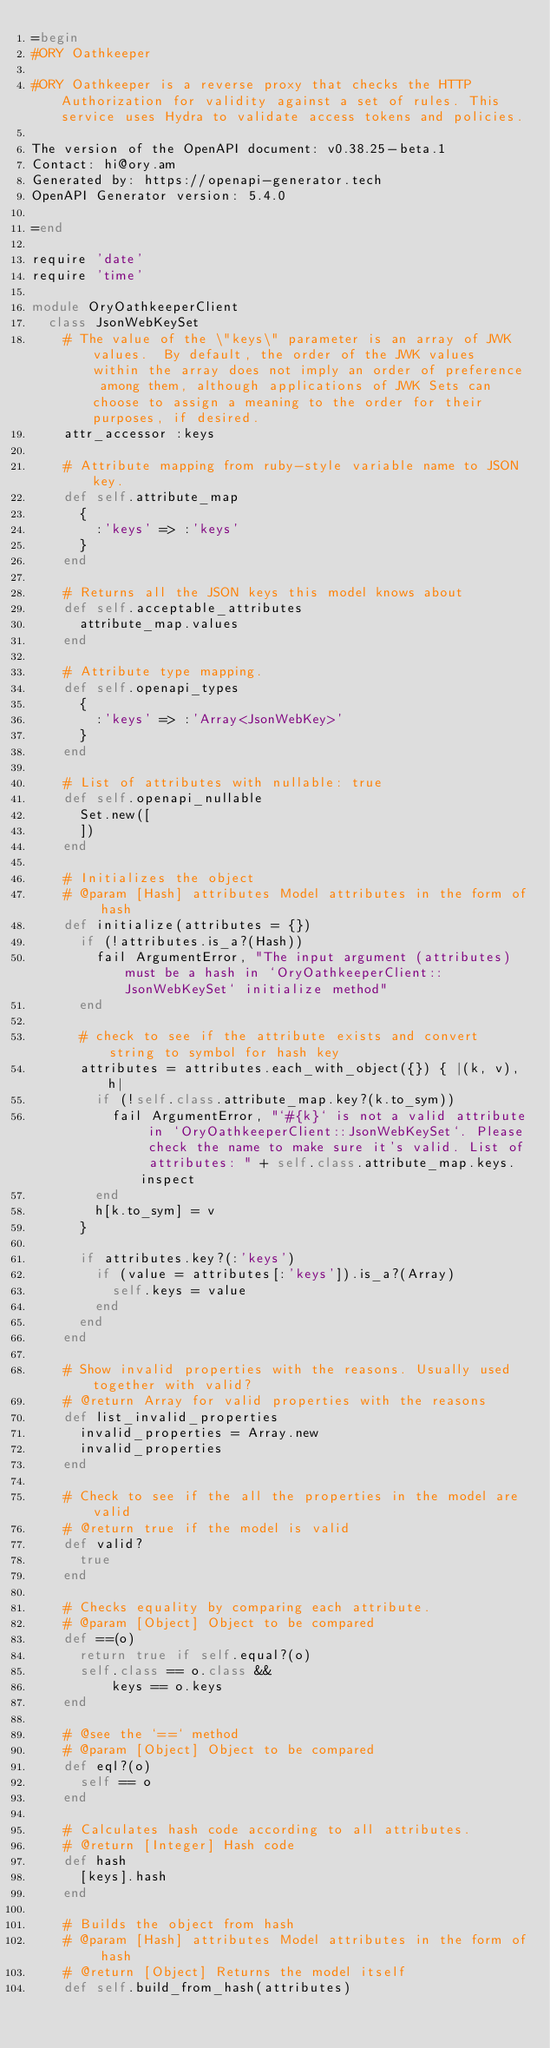<code> <loc_0><loc_0><loc_500><loc_500><_Ruby_>=begin
#ORY Oathkeeper

#ORY Oathkeeper is a reverse proxy that checks the HTTP Authorization for validity against a set of rules. This service uses Hydra to validate access tokens and policies.

The version of the OpenAPI document: v0.38.25-beta.1
Contact: hi@ory.am
Generated by: https://openapi-generator.tech
OpenAPI Generator version: 5.4.0

=end

require 'date'
require 'time'

module OryOathkeeperClient
  class JsonWebKeySet
    # The value of the \"keys\" parameter is an array of JWK values.  By default, the order of the JWK values within the array does not imply an order of preference among them, although applications of JWK Sets can choose to assign a meaning to the order for their purposes, if desired.
    attr_accessor :keys

    # Attribute mapping from ruby-style variable name to JSON key.
    def self.attribute_map
      {
        :'keys' => :'keys'
      }
    end

    # Returns all the JSON keys this model knows about
    def self.acceptable_attributes
      attribute_map.values
    end

    # Attribute type mapping.
    def self.openapi_types
      {
        :'keys' => :'Array<JsonWebKey>'
      }
    end

    # List of attributes with nullable: true
    def self.openapi_nullable
      Set.new([
      ])
    end

    # Initializes the object
    # @param [Hash] attributes Model attributes in the form of hash
    def initialize(attributes = {})
      if (!attributes.is_a?(Hash))
        fail ArgumentError, "The input argument (attributes) must be a hash in `OryOathkeeperClient::JsonWebKeySet` initialize method"
      end

      # check to see if the attribute exists and convert string to symbol for hash key
      attributes = attributes.each_with_object({}) { |(k, v), h|
        if (!self.class.attribute_map.key?(k.to_sym))
          fail ArgumentError, "`#{k}` is not a valid attribute in `OryOathkeeperClient::JsonWebKeySet`. Please check the name to make sure it's valid. List of attributes: " + self.class.attribute_map.keys.inspect
        end
        h[k.to_sym] = v
      }

      if attributes.key?(:'keys')
        if (value = attributes[:'keys']).is_a?(Array)
          self.keys = value
        end
      end
    end

    # Show invalid properties with the reasons. Usually used together with valid?
    # @return Array for valid properties with the reasons
    def list_invalid_properties
      invalid_properties = Array.new
      invalid_properties
    end

    # Check to see if the all the properties in the model are valid
    # @return true if the model is valid
    def valid?
      true
    end

    # Checks equality by comparing each attribute.
    # @param [Object] Object to be compared
    def ==(o)
      return true if self.equal?(o)
      self.class == o.class &&
          keys == o.keys
    end

    # @see the `==` method
    # @param [Object] Object to be compared
    def eql?(o)
      self == o
    end

    # Calculates hash code according to all attributes.
    # @return [Integer] Hash code
    def hash
      [keys].hash
    end

    # Builds the object from hash
    # @param [Hash] attributes Model attributes in the form of hash
    # @return [Object] Returns the model itself
    def self.build_from_hash(attributes)</code> 